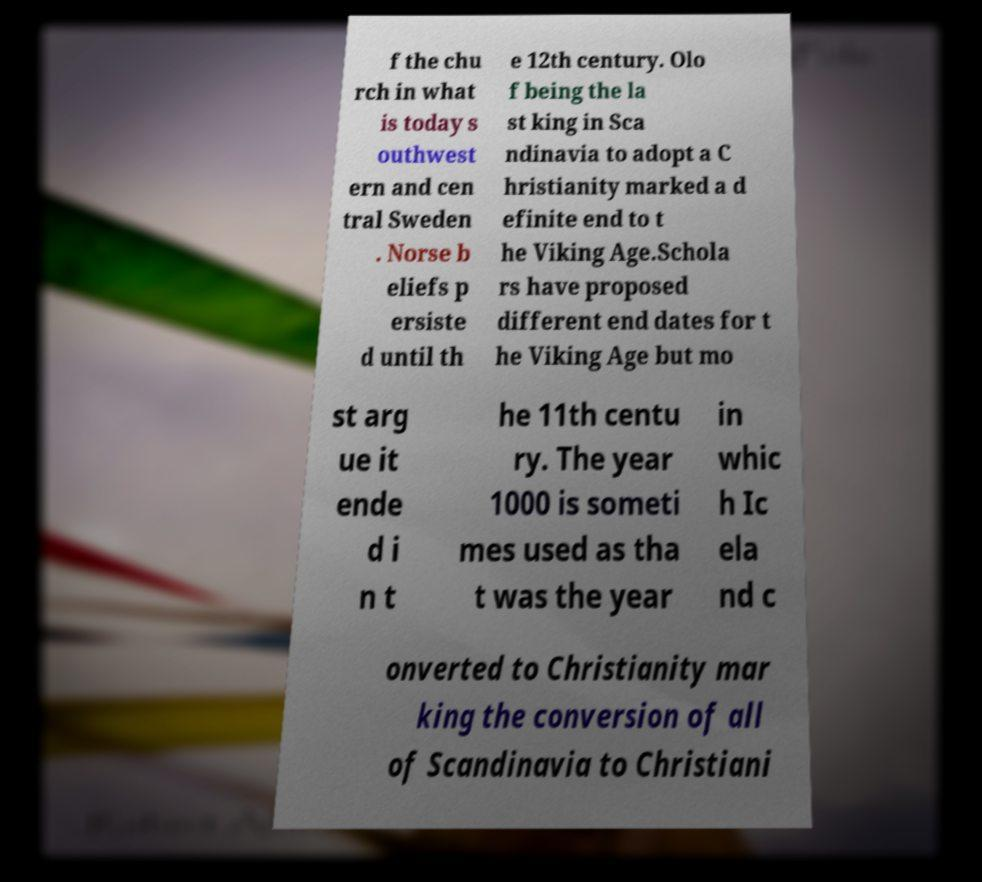Please identify and transcribe the text found in this image. f the chu rch in what is today s outhwest ern and cen tral Sweden . Norse b eliefs p ersiste d until th e 12th century. Olo f being the la st king in Sca ndinavia to adopt a C hristianity marked a d efinite end to t he Viking Age.Schola rs have proposed different end dates for t he Viking Age but mo st arg ue it ende d i n t he 11th centu ry. The year 1000 is someti mes used as tha t was the year in whic h Ic ela nd c onverted to Christianity mar king the conversion of all of Scandinavia to Christiani 